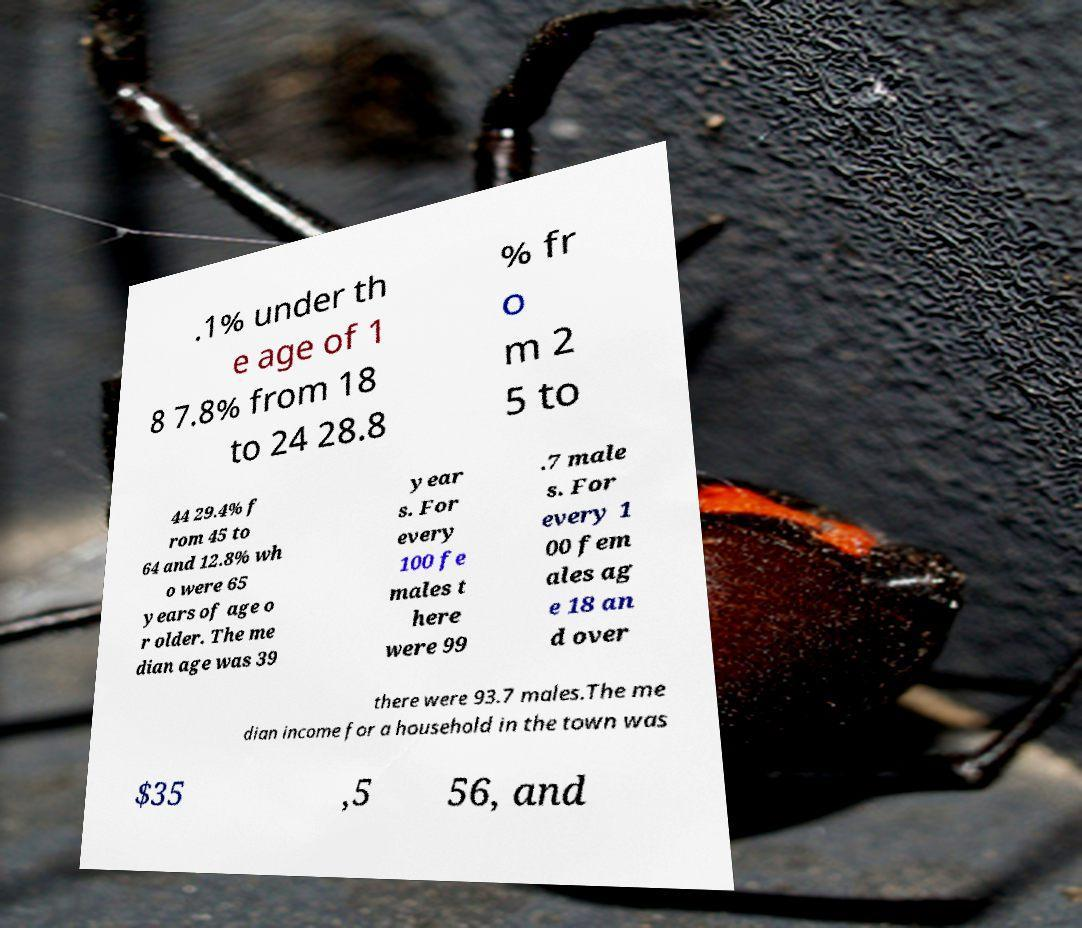Please identify and transcribe the text found in this image. .1% under th e age of 1 8 7.8% from 18 to 24 28.8 % fr o m 2 5 to 44 29.4% f rom 45 to 64 and 12.8% wh o were 65 years of age o r older. The me dian age was 39 year s. For every 100 fe males t here were 99 .7 male s. For every 1 00 fem ales ag e 18 an d over there were 93.7 males.The me dian income for a household in the town was $35 ,5 56, and 